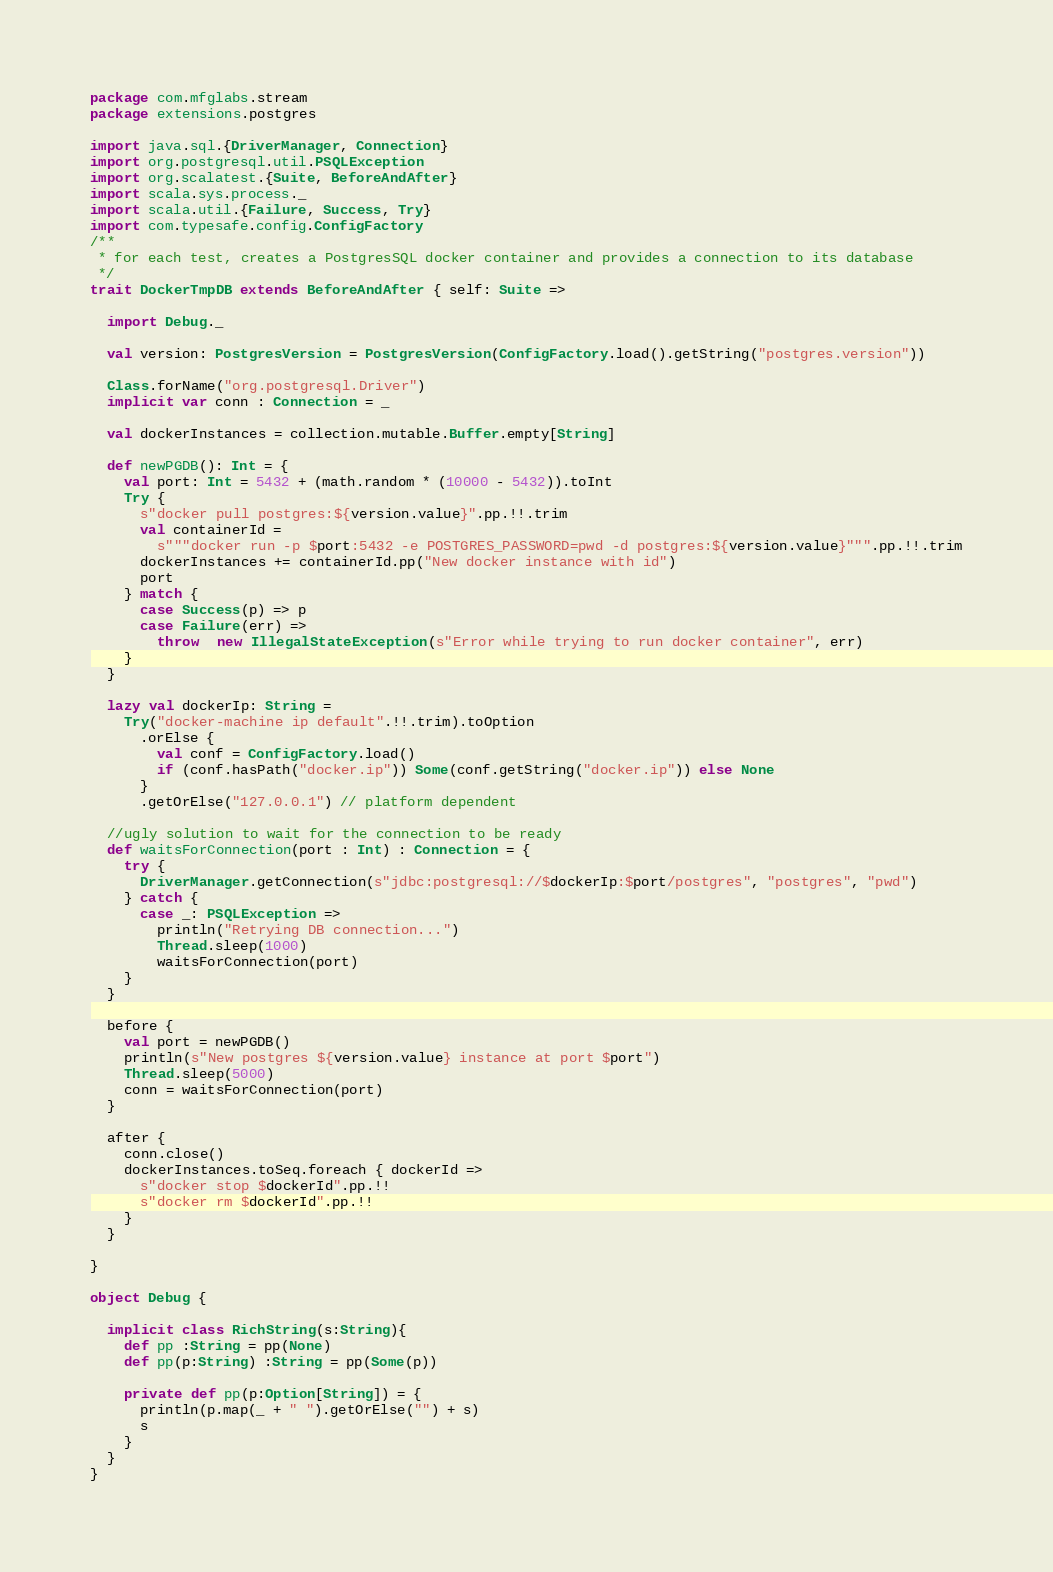<code> <loc_0><loc_0><loc_500><loc_500><_Scala_>package com.mfglabs.stream
package extensions.postgres

import java.sql.{DriverManager, Connection}
import org.postgresql.util.PSQLException
import org.scalatest.{Suite, BeforeAndAfter}
import scala.sys.process._
import scala.util.{Failure, Success, Try}
import com.typesafe.config.ConfigFactory
/**
 * for each test, creates a PostgresSQL docker container and provides a connection to its database
 */
trait DockerTmpDB extends BeforeAndAfter { self: Suite =>

  import Debug._

  val version: PostgresVersion = PostgresVersion(ConfigFactory.load().getString("postgres.version"))

  Class.forName("org.postgresql.Driver")
  implicit var conn : Connection = _

  val dockerInstances = collection.mutable.Buffer.empty[String]

  def newPGDB(): Int = {
    val port: Int = 5432 + (math.random * (10000 - 5432)).toInt
    Try {
      s"docker pull postgres:${version.value}".pp.!!.trim
      val containerId =
        s"""docker run -p $port:5432 -e POSTGRES_PASSWORD=pwd -d postgres:${version.value}""".pp.!!.trim
      dockerInstances += containerId.pp("New docker instance with id")
      port
    } match {
      case Success(p) => p
      case Failure(err) =>
        throw  new IllegalStateException(s"Error while trying to run docker container", err)
    }
  }

  lazy val dockerIp: String =
    Try("docker-machine ip default".!!.trim).toOption
      .orElse {
        val conf = ConfigFactory.load()
        if (conf.hasPath("docker.ip")) Some(conf.getString("docker.ip")) else None
      }
      .getOrElse("127.0.0.1") // platform dependent

  //ugly solution to wait for the connection to be ready
  def waitsForConnection(port : Int) : Connection = {
    try {
      DriverManager.getConnection(s"jdbc:postgresql://$dockerIp:$port/postgres", "postgres", "pwd")
    } catch {
      case _: PSQLException =>
        println("Retrying DB connection...")
        Thread.sleep(1000)
        waitsForConnection(port)
    }
  }

  before {
    val port = newPGDB()
    println(s"New postgres ${version.value} instance at port $port")
    Thread.sleep(5000)
    conn = waitsForConnection(port)
  }

  after {
    conn.close()
    dockerInstances.toSeq.foreach { dockerId =>
      s"docker stop $dockerId".pp.!!
      s"docker rm $dockerId".pp.!!
    }
  }

}

object Debug {

  implicit class RichString(s:String){
    def pp :String = pp(None)
    def pp(p:String) :String = pp(Some(p))

    private def pp(p:Option[String]) = {
      println(p.map(_ + " ").getOrElse("") + s)
      s
    }
  }
}


</code> 